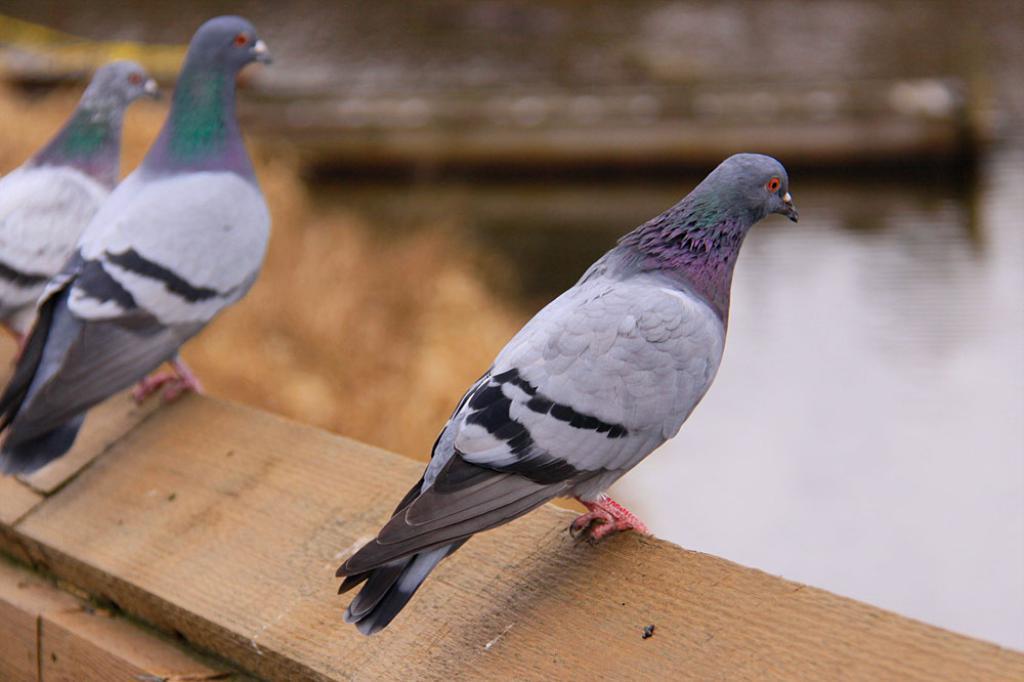In one or two sentences, can you explain what this image depicts? This picture is clicked outside and in the foreground we can see the pigeons standing on the wooden plank. In the background we can see a water body and the dry grass and some other objects. 